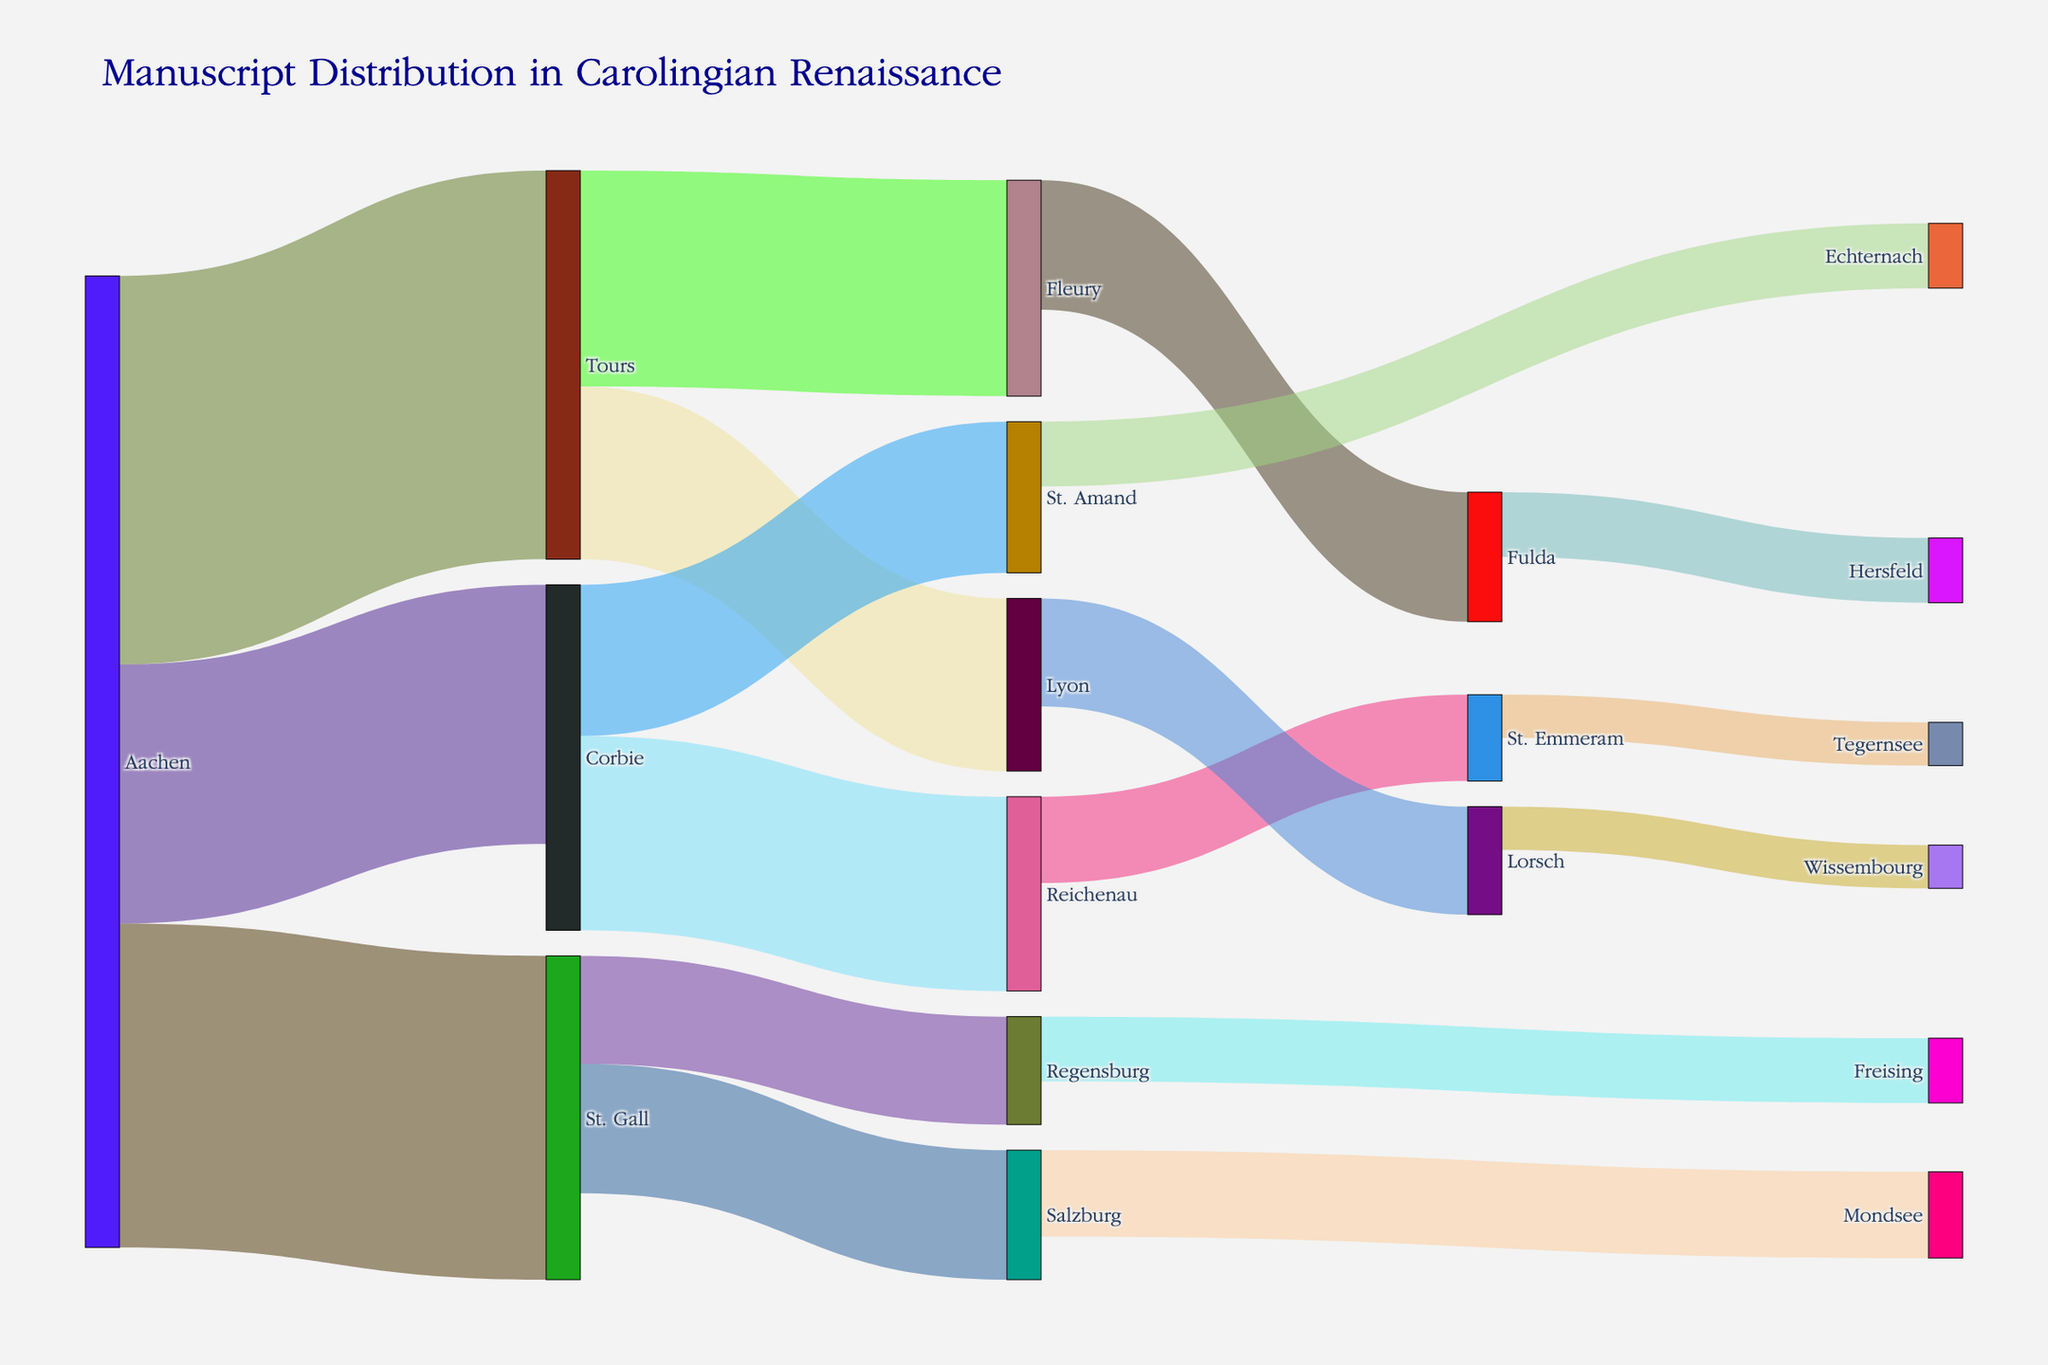what is the largest number of manuscripts transferred from Aachen? The Sankey Diagram shows the flow of manuscripts from Aachen to different centers. The largest value of manuscripts from Aachen is the widest link in the diagram. Here, Aachen to Tours has the largest number, represented by 18.
Answer: 18 which route has the minimum number of manuscript transfers? To find the route with the minimum number of transfers, observe the narrowest link in the diagram. This smallest value corresponds to Lorsch to Wissembourg, represented by 2.
Answer: Lorsch to Wissembourg how many total manuscripts were distributed from Tours? To find the total number of manuscripts distributed from Tours, sum the values of all outgoing links from Tours. These values are 10 (Tours to Fleury) and 8 (Tours to Lyon). Adding them up gives 10 + 8 = 18.
Answer: 18 which center received the highest number of manuscripts? To determine which center received the most manuscripts, look for the node with the thickest incoming links. St. Gall receives the highest total with 15 manuscripts from Aachen and 6 from Reichenau, total being 21.
Answer: St. Gall how does the flow from Corbie to its centers compare to the flow from St. Gall? To compare, sum the values of outgoing links from Corbie and St. Gall. Corbie has 9 (to Reichenau) + 7 (to St. Amand) = 16. St. Gall has 6 (to Salzburg) + 5 (to Regensburg) = 11. Comparatively, Corbie has more manuscripts distributed.
Answer: Corbie has more manuscripts distributed how many total manuscript transfers are there in the diagram? Sum all the values represented by the links in the Sankey Diagram. Adding all given values: 15+12+18+10+8+9+7+6+5+4+6+5+3+4+3+2 = 117 manuscripts.
Answer: 117 what percentage of Aachen's manuscripts were sent to Tours? Divide the number of manuscripts sent from Aachen to Tours by the total manuscripts from Aachen, then multiply by 100. Total from Aachen is 15+12+18 = 45, so (18/45) * 100 = 40%.
Answer: 40% which center received manuscripts from multiple sources? By following the incoming links, St. Emmeram receives manuscripts from multiple sources: Reichenau (4 manuscripts) and Tegernsee (2 manuscripts).
Answer: St. Emmeram which outflow from Corbie had the smallest transfer? Look at the outgoing links from Corbie to find the smallest value. Corbie to St. Amand with 7 manuscripts is the smallest.
Answer: Corbie to St. Amand 